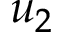Convert formula to latex. <formula><loc_0><loc_0><loc_500><loc_500>u _ { 2 }</formula> 